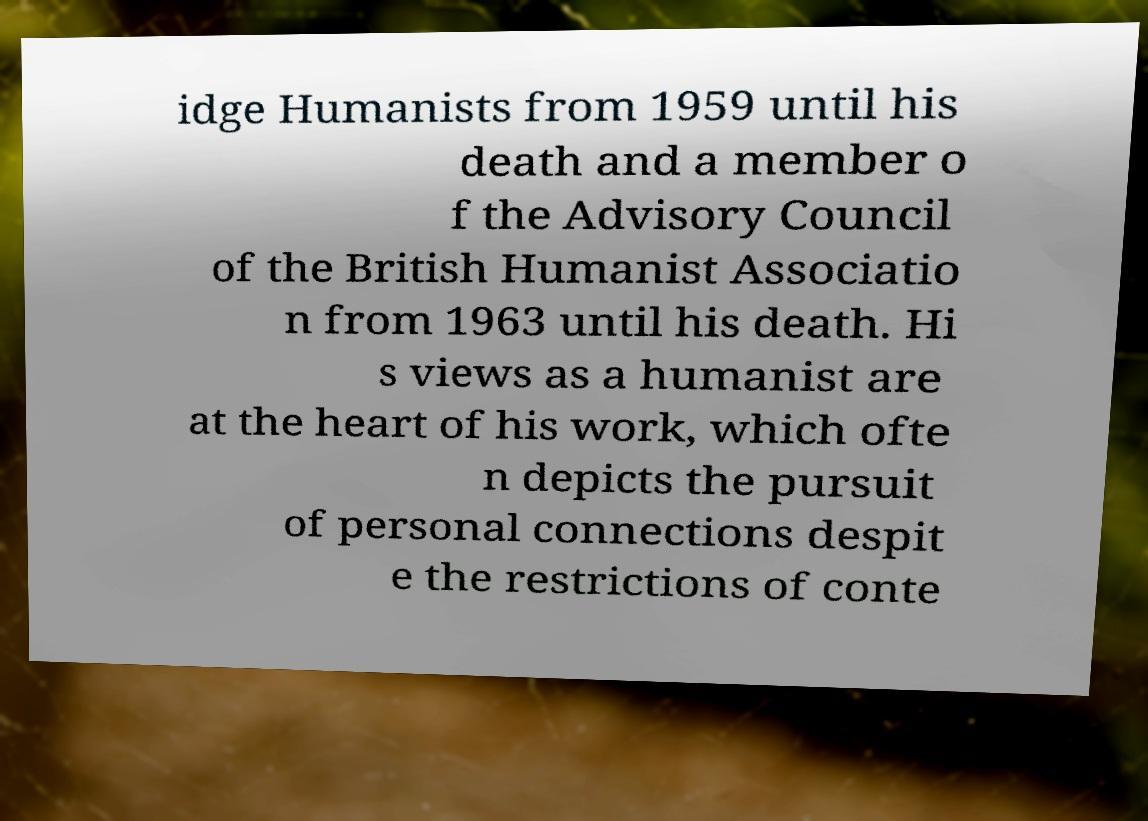Could you extract and type out the text from this image? idge Humanists from 1959 until his death and a member o f the Advisory Council of the British Humanist Associatio n from 1963 until his death. Hi s views as a humanist are at the heart of his work, which ofte n depicts the pursuit of personal connections despit e the restrictions of conte 